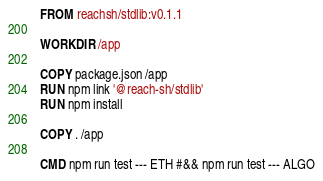Convert code to text. <code><loc_0><loc_0><loc_500><loc_500><_Dockerfile_>FROM reachsh/stdlib:v0.1.1

WORKDIR /app

COPY package.json /app
RUN npm link '@reach-sh/stdlib'
RUN npm install

COPY . /app

CMD npm run test --- ETH #&& npm run test --- ALGO
</code> 